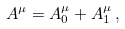Convert formula to latex. <formula><loc_0><loc_0><loc_500><loc_500>A ^ { \mu } = A _ { 0 } ^ { \mu } + A _ { 1 } ^ { \mu } \, ,</formula> 